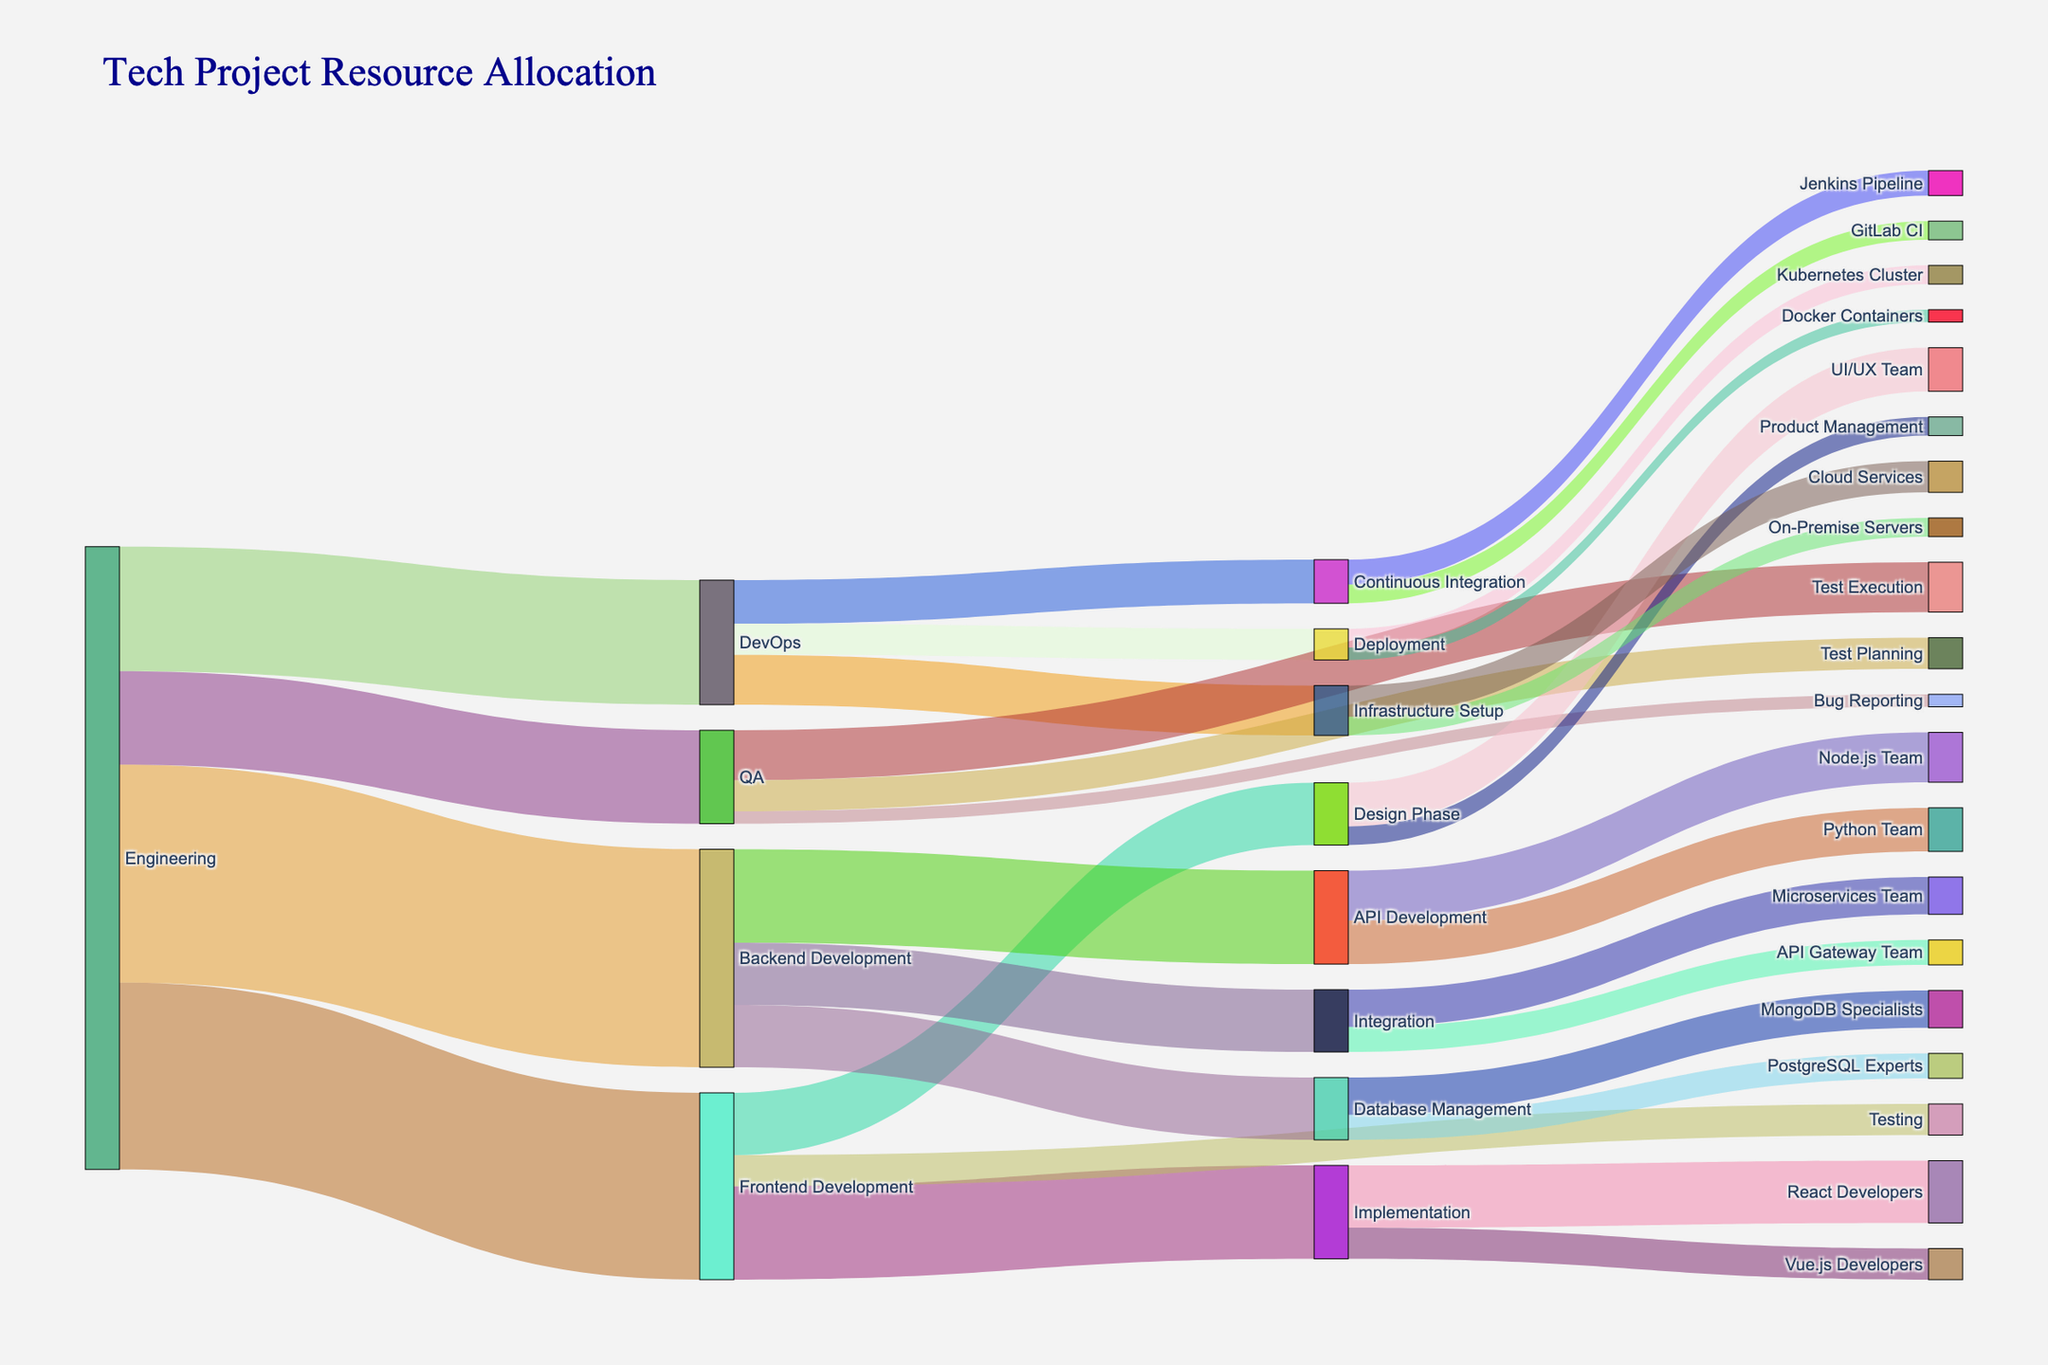Which team has the largest allocation from Engineering? From the Sankey diagram, we can see the width of the flows coming out of Engineering. The largest flow goes to Backend Development, where the value is 35.
Answer: Backend Development How many resources are allocated to Testing within Frontend Development? The flow labeled "Testing" within the Frontend Development section has a value of 5.
Answer: 5 What's the total resource allocation to the QA team? The flow values from Engineering to QA are 15, and within QA, the resources are distributed as 5 (Test Planning) + 8 (Test Execution) + 2 (Bug Reporting). Adding these up gives us 15.
Answer: 15 Which phase in Backend Development receives more resources, API Development or Database Management? By comparing the values, API Development receives 15 resources, whereas Database Management receives a total of 10. Therefore, API Development gets more resources.
Answer: API Development What's the overall resource allocation to Implementation within Frontend Development? In Frontend Development, the resources allocated to Implementation are 15. Therefore, the total resource allocation to Implementation is 15.
Answer: 15 From DevOps, which phase receives the least resources? By comparing the values, Deployment receives the least resources from DevOps with a value of 5.
Answer: Deployment What is the combined resource allocation for Infrastructure Setup and Continuous Integration within DevOps? Infrastructure Setup has 8 and Continuous Integration has 7 resources within DevOps. Summing these values gives us 8 + 7 = 15.
Answer: 15 Which specific team within QA receives the highest resource allocation? Test Execution within QA receives the highest resource allocation with a value of 8.
Answer: Test Execution How do the resources allocated to React Developers compare with those allocated to Vue.js Developers? The resources allocated to React Developers are 10, while those allocated to Vue.js Developers are 5. Hence, React Developers receive more resources.
Answer: React Developers 